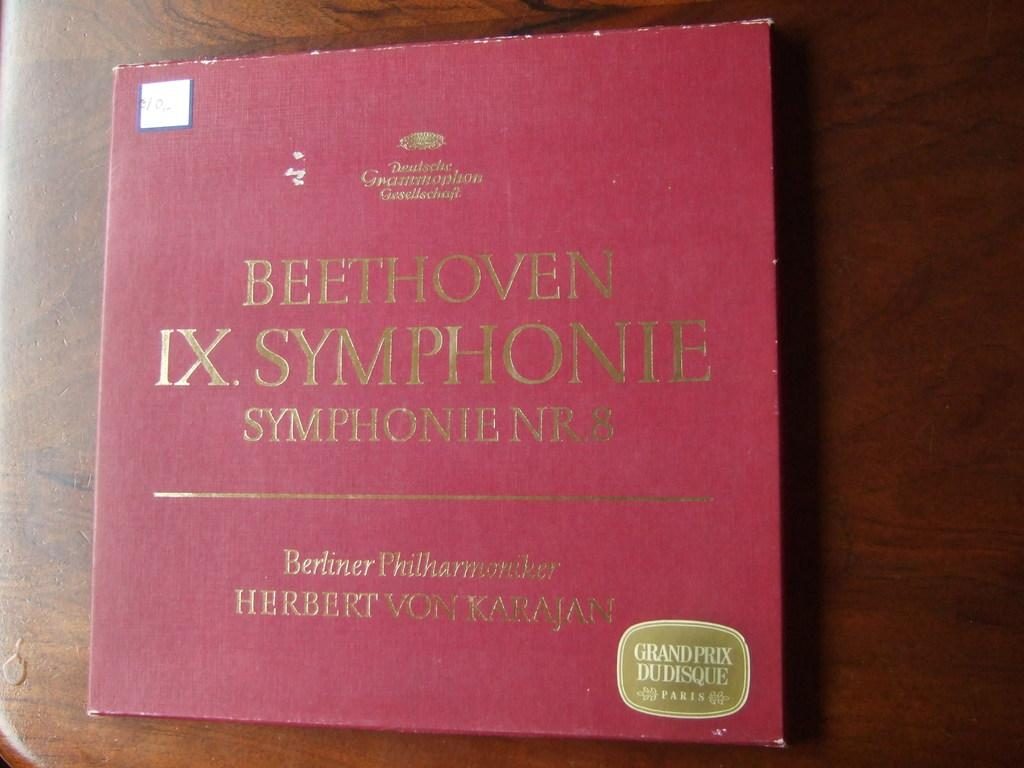<image>
Relay a brief, clear account of the picture shown. Some music CDs feature classical music by Beethoven. 